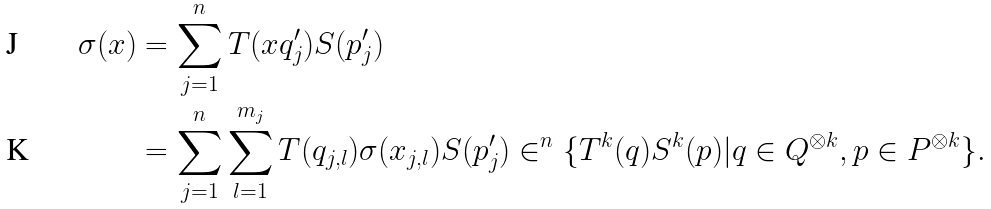<formula> <loc_0><loc_0><loc_500><loc_500>\sigma ( x ) & = \sum _ { j = 1 } ^ { n } T ( x q ^ { \prime } _ { j } ) S ( p ^ { \prime } _ { j } ) \\ & = \sum _ { j = 1 } ^ { n } \sum _ { l = 1 } ^ { m _ { j } } T ( q _ { j , l } ) \sigma ( x _ { j , l } ) S ( p ^ { \prime } _ { j } ) \in ^ { n } \{ T ^ { k } ( q ) S ^ { k } ( p ) | q \in Q ^ { \otimes k } , p \in P ^ { \otimes k } \} .</formula> 